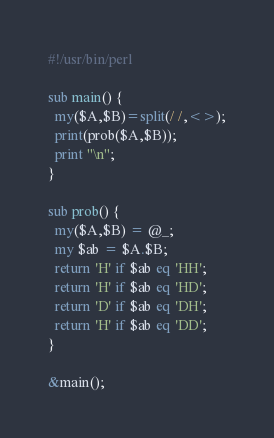Convert code to text. <code><loc_0><loc_0><loc_500><loc_500><_Perl_>#!/usr/bin/perl

sub main() {
  my($A,$B)=split(/ /,<>);
  print(prob($A,$B));
  print "\n";
}

sub prob() {
  my($A,$B) = @_;
  my $ab = $A.$B;
  return 'H' if $ab eq 'HH';
  return 'H' if $ab eq 'HD';
  return 'D' if $ab eq 'DH';
  return 'H' if $ab eq 'DD';
}

&main();</code> 